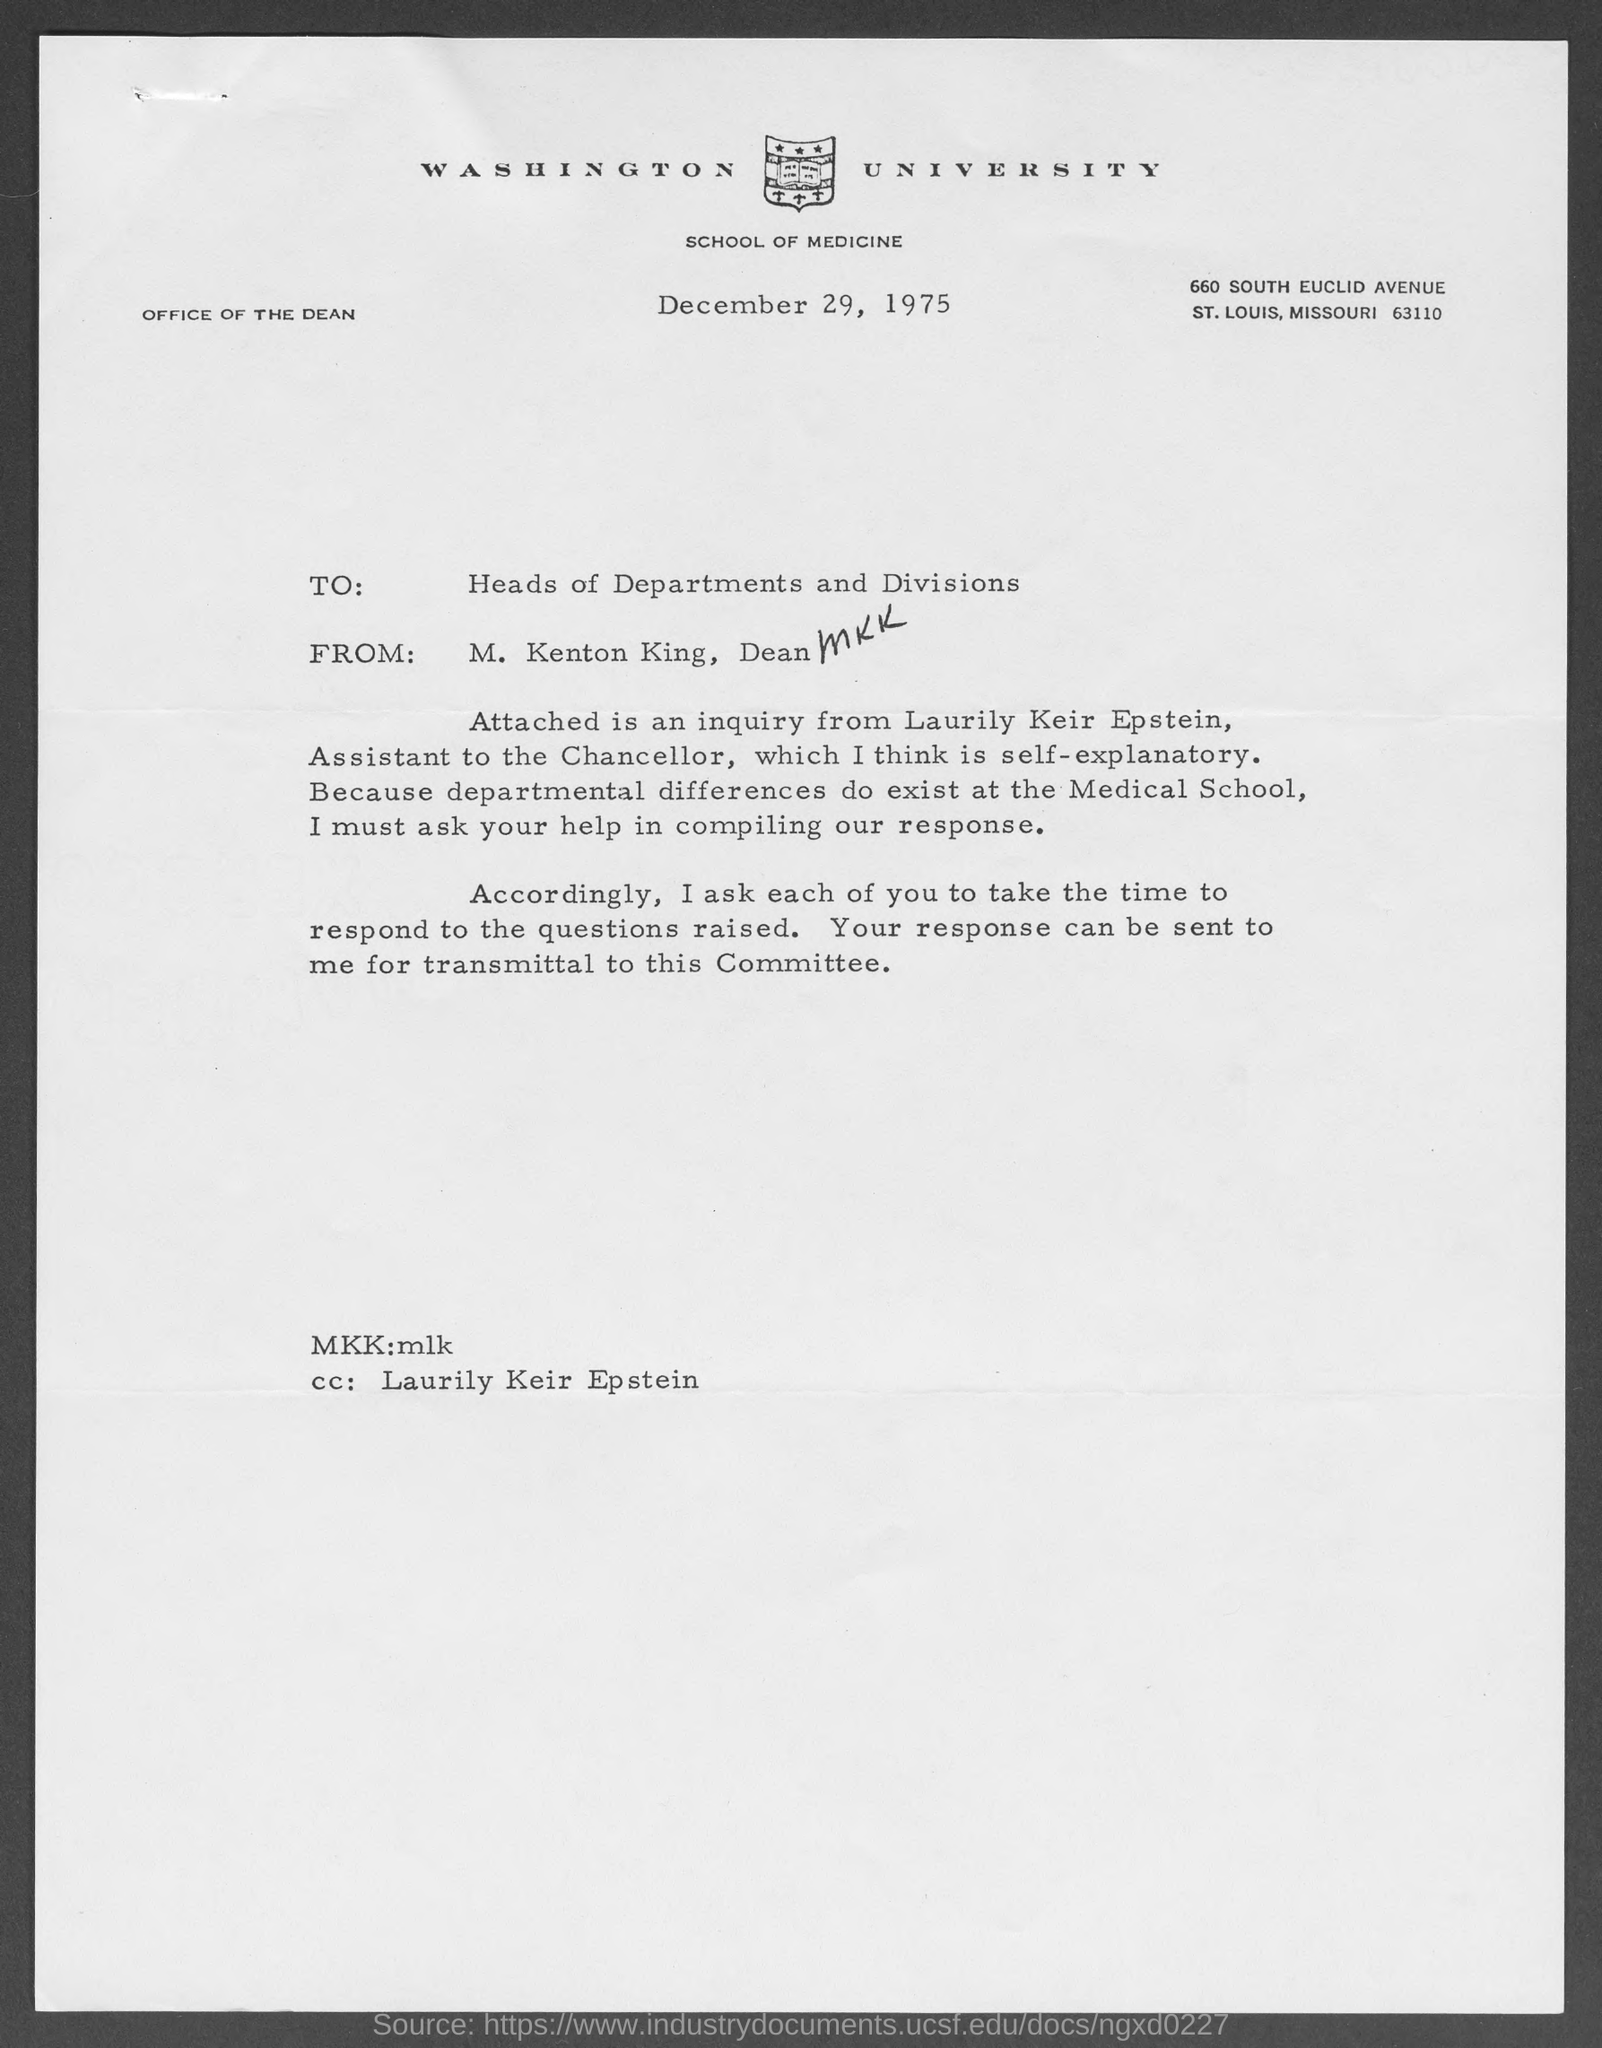Specify some key components in this picture. The letter was written by M. Kenton King. M. Kenton King is the Dean. The letter is dated December 29, 1975. The avenue address of Washington University School of Medicine is located at 660 South Euclid Avenue. 